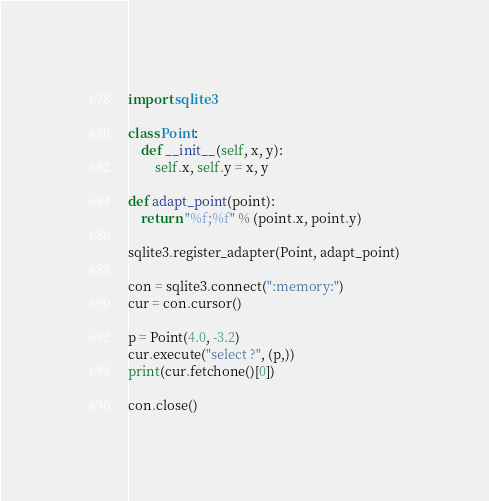<code> <loc_0><loc_0><loc_500><loc_500><_Python_>import sqlite3

class Point:
    def __init__(self, x, y):
        self.x, self.y = x, y

def adapt_point(point):
    return "%f;%f" % (point.x, point.y)

sqlite3.register_adapter(Point, adapt_point)

con = sqlite3.connect(":memory:")
cur = con.cursor()

p = Point(4.0, -3.2)
cur.execute("select ?", (p,))
print(cur.fetchone()[0])

con.close()
</code> 